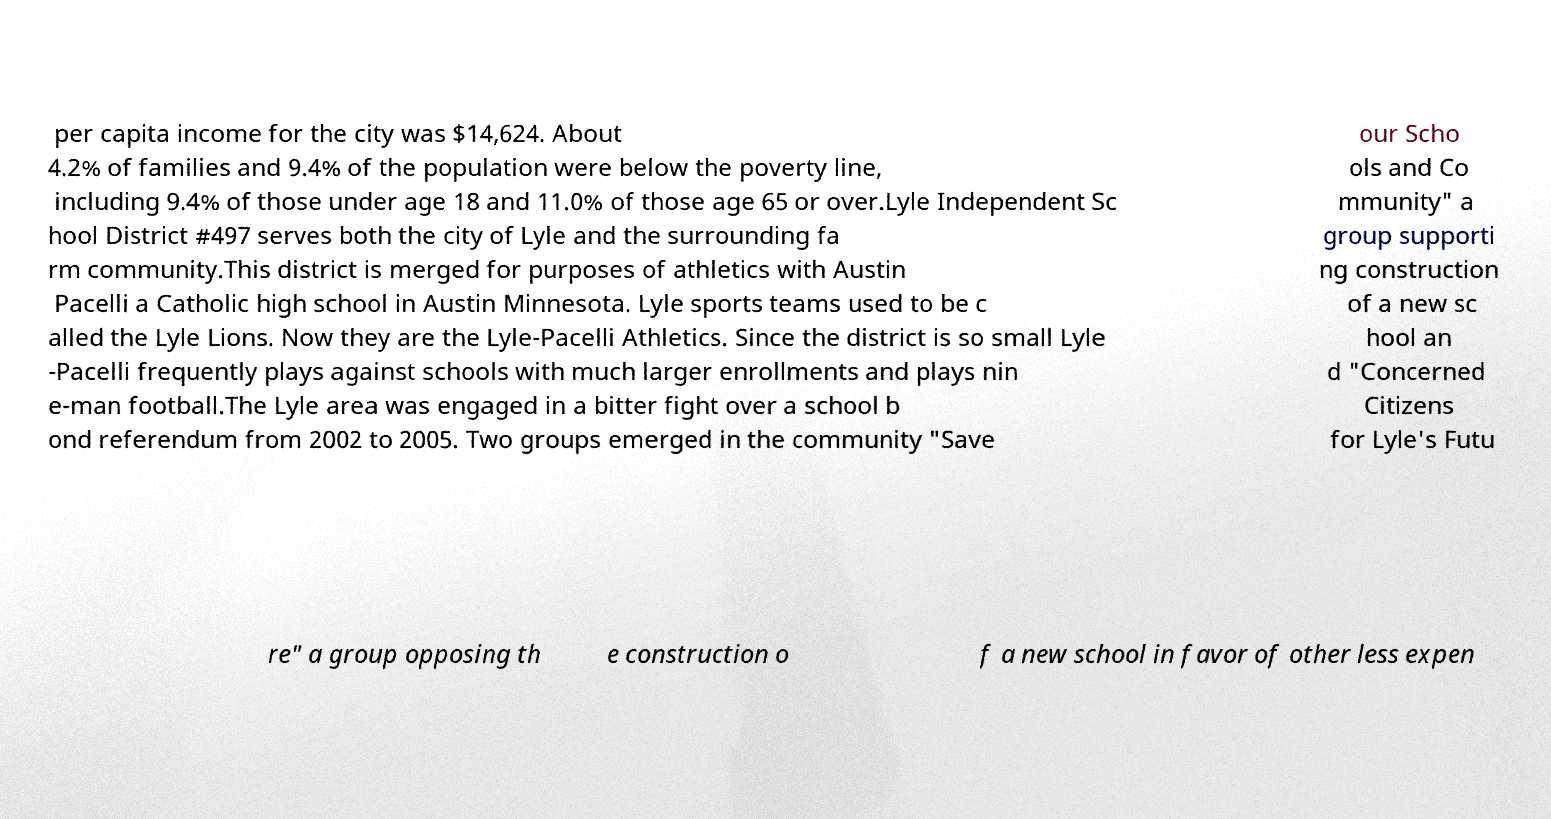There's text embedded in this image that I need extracted. Can you transcribe it verbatim? per capita income for the city was $14,624. About 4.2% of families and 9.4% of the population were below the poverty line, including 9.4% of those under age 18 and 11.0% of those age 65 or over.Lyle Independent Sc hool District #497 serves both the city of Lyle and the surrounding fa rm community.This district is merged for purposes of athletics with Austin Pacelli a Catholic high school in Austin Minnesota. Lyle sports teams used to be c alled the Lyle Lions. Now they are the Lyle-Pacelli Athletics. Since the district is so small Lyle -Pacelli frequently plays against schools with much larger enrollments and plays nin e-man football.The Lyle area was engaged in a bitter fight over a school b ond referendum from 2002 to 2005. Two groups emerged in the community "Save our Scho ols and Co mmunity" a group supporti ng construction of a new sc hool an d "Concerned Citizens for Lyle's Futu re" a group opposing th e construction o f a new school in favor of other less expen 